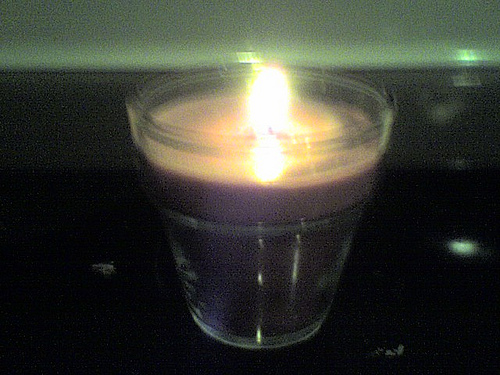<image>
Is the candle to the left of the fire? No. The candle is not to the left of the fire. From this viewpoint, they have a different horizontal relationship. Where is the light in relation to the glass? Is it in the glass? Yes. The light is contained within or inside the glass, showing a containment relationship. 